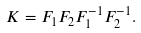<formula> <loc_0><loc_0><loc_500><loc_500>K = F _ { 1 } F _ { 2 } F ^ { - 1 } _ { 1 } F ^ { - 1 } _ { 2 } .</formula> 